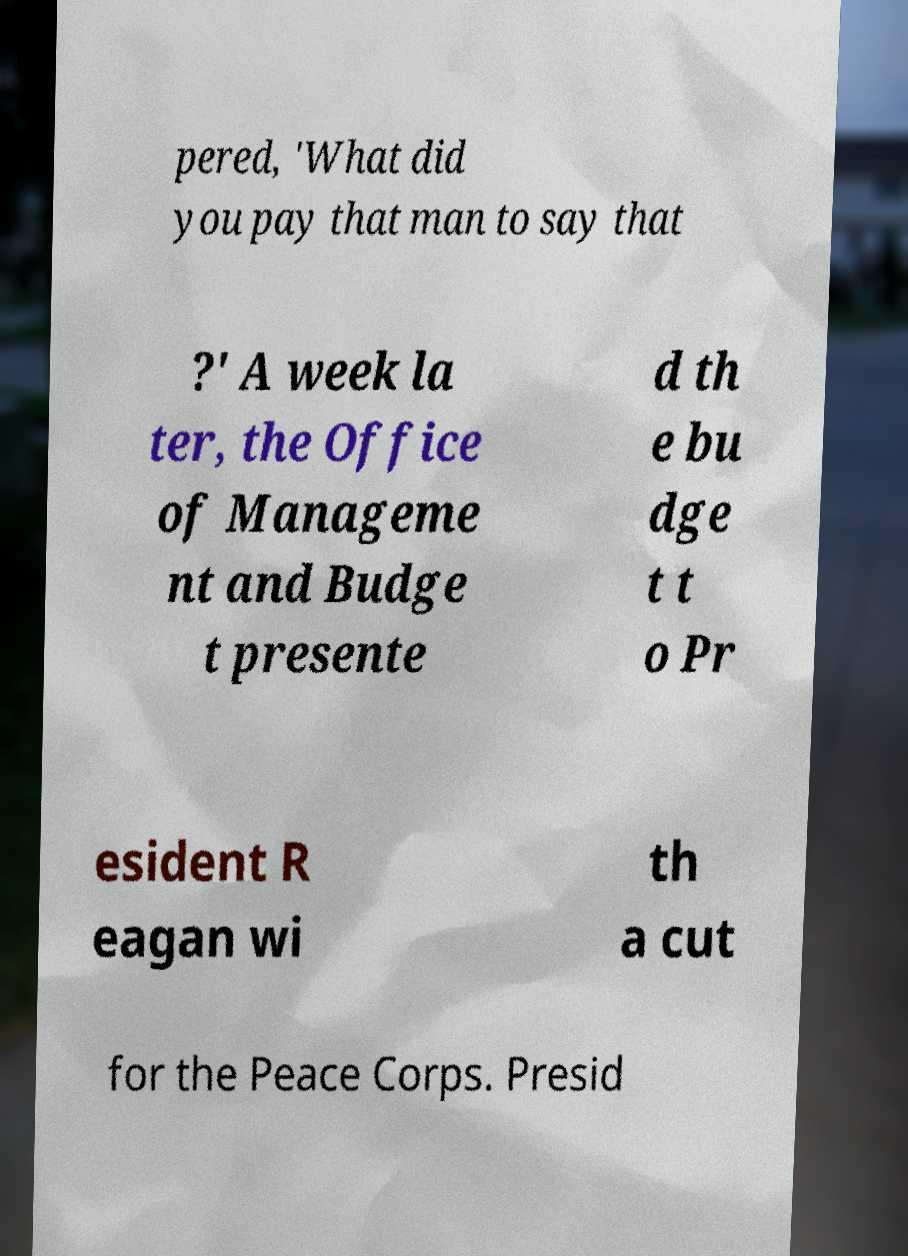Can you accurately transcribe the text from the provided image for me? pered, 'What did you pay that man to say that ?' A week la ter, the Office of Manageme nt and Budge t presente d th e bu dge t t o Pr esident R eagan wi th a cut for the Peace Corps. Presid 